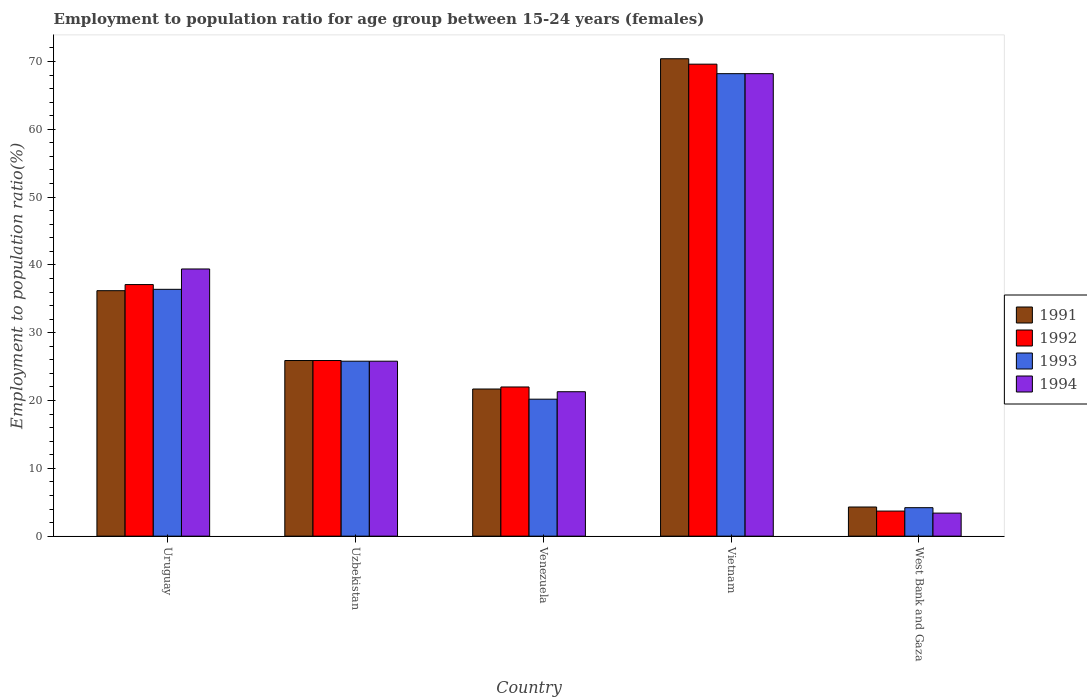How many different coloured bars are there?
Ensure brevity in your answer.  4. How many bars are there on the 4th tick from the right?
Provide a succinct answer. 4. What is the label of the 2nd group of bars from the left?
Your answer should be very brief. Uzbekistan. What is the employment to population ratio in 1993 in Uzbekistan?
Make the answer very short. 25.8. Across all countries, what is the maximum employment to population ratio in 1993?
Your response must be concise. 68.2. Across all countries, what is the minimum employment to population ratio in 1991?
Offer a terse response. 4.3. In which country was the employment to population ratio in 1993 maximum?
Provide a succinct answer. Vietnam. In which country was the employment to population ratio in 1992 minimum?
Provide a succinct answer. West Bank and Gaza. What is the total employment to population ratio in 1993 in the graph?
Keep it short and to the point. 154.8. What is the difference between the employment to population ratio in 1993 in Venezuela and that in Vietnam?
Offer a terse response. -48. What is the difference between the employment to population ratio in 1991 in Uzbekistan and the employment to population ratio in 1992 in Venezuela?
Your response must be concise. 3.9. What is the average employment to population ratio in 1993 per country?
Provide a succinct answer. 30.96. What is the difference between the employment to population ratio of/in 1993 and employment to population ratio of/in 1992 in Venezuela?
Provide a short and direct response. -1.8. In how many countries, is the employment to population ratio in 1991 greater than 8 %?
Offer a very short reply. 4. What is the ratio of the employment to population ratio in 1993 in Vietnam to that in West Bank and Gaza?
Provide a succinct answer. 16.24. Is the employment to population ratio in 1993 in Uruguay less than that in West Bank and Gaza?
Provide a succinct answer. No. What is the difference between the highest and the second highest employment to population ratio in 1992?
Make the answer very short. -11.2. What is the difference between the highest and the lowest employment to population ratio in 1991?
Provide a succinct answer. 66.1. Is it the case that in every country, the sum of the employment to population ratio in 1993 and employment to population ratio in 1991 is greater than the sum of employment to population ratio in 1992 and employment to population ratio in 1994?
Give a very brief answer. No. What does the 4th bar from the left in Venezuela represents?
Make the answer very short. 1994. What does the 2nd bar from the right in Venezuela represents?
Make the answer very short. 1993. How many bars are there?
Offer a very short reply. 20. How many countries are there in the graph?
Keep it short and to the point. 5. What is the difference between two consecutive major ticks on the Y-axis?
Give a very brief answer. 10. Are the values on the major ticks of Y-axis written in scientific E-notation?
Provide a succinct answer. No. Does the graph contain any zero values?
Your answer should be very brief. No. Does the graph contain grids?
Your answer should be compact. No. How many legend labels are there?
Give a very brief answer. 4. How are the legend labels stacked?
Ensure brevity in your answer.  Vertical. What is the title of the graph?
Your response must be concise. Employment to population ratio for age group between 15-24 years (females). Does "1976" appear as one of the legend labels in the graph?
Your response must be concise. No. What is the label or title of the X-axis?
Your response must be concise. Country. What is the label or title of the Y-axis?
Make the answer very short. Employment to population ratio(%). What is the Employment to population ratio(%) of 1991 in Uruguay?
Offer a terse response. 36.2. What is the Employment to population ratio(%) of 1992 in Uruguay?
Give a very brief answer. 37.1. What is the Employment to population ratio(%) in 1993 in Uruguay?
Provide a short and direct response. 36.4. What is the Employment to population ratio(%) of 1994 in Uruguay?
Provide a succinct answer. 39.4. What is the Employment to population ratio(%) in 1991 in Uzbekistan?
Offer a terse response. 25.9. What is the Employment to population ratio(%) of 1992 in Uzbekistan?
Ensure brevity in your answer.  25.9. What is the Employment to population ratio(%) in 1993 in Uzbekistan?
Make the answer very short. 25.8. What is the Employment to population ratio(%) of 1994 in Uzbekistan?
Your response must be concise. 25.8. What is the Employment to population ratio(%) in 1991 in Venezuela?
Offer a very short reply. 21.7. What is the Employment to population ratio(%) of 1992 in Venezuela?
Your answer should be very brief. 22. What is the Employment to population ratio(%) of 1993 in Venezuela?
Ensure brevity in your answer.  20.2. What is the Employment to population ratio(%) in 1994 in Venezuela?
Provide a short and direct response. 21.3. What is the Employment to population ratio(%) of 1991 in Vietnam?
Offer a very short reply. 70.4. What is the Employment to population ratio(%) in 1992 in Vietnam?
Make the answer very short. 69.6. What is the Employment to population ratio(%) in 1993 in Vietnam?
Your answer should be very brief. 68.2. What is the Employment to population ratio(%) in 1994 in Vietnam?
Offer a terse response. 68.2. What is the Employment to population ratio(%) in 1991 in West Bank and Gaza?
Offer a terse response. 4.3. What is the Employment to population ratio(%) in 1992 in West Bank and Gaza?
Your answer should be very brief. 3.7. What is the Employment to population ratio(%) in 1993 in West Bank and Gaza?
Your response must be concise. 4.2. What is the Employment to population ratio(%) in 1994 in West Bank and Gaza?
Offer a very short reply. 3.4. Across all countries, what is the maximum Employment to population ratio(%) in 1991?
Keep it short and to the point. 70.4. Across all countries, what is the maximum Employment to population ratio(%) of 1992?
Ensure brevity in your answer.  69.6. Across all countries, what is the maximum Employment to population ratio(%) in 1993?
Your response must be concise. 68.2. Across all countries, what is the maximum Employment to population ratio(%) in 1994?
Ensure brevity in your answer.  68.2. Across all countries, what is the minimum Employment to population ratio(%) of 1991?
Your response must be concise. 4.3. Across all countries, what is the minimum Employment to population ratio(%) in 1992?
Your answer should be compact. 3.7. Across all countries, what is the minimum Employment to population ratio(%) of 1993?
Provide a short and direct response. 4.2. Across all countries, what is the minimum Employment to population ratio(%) in 1994?
Ensure brevity in your answer.  3.4. What is the total Employment to population ratio(%) of 1991 in the graph?
Ensure brevity in your answer.  158.5. What is the total Employment to population ratio(%) in 1992 in the graph?
Make the answer very short. 158.3. What is the total Employment to population ratio(%) of 1993 in the graph?
Keep it short and to the point. 154.8. What is the total Employment to population ratio(%) in 1994 in the graph?
Keep it short and to the point. 158.1. What is the difference between the Employment to population ratio(%) of 1991 in Uruguay and that in Uzbekistan?
Your answer should be very brief. 10.3. What is the difference between the Employment to population ratio(%) of 1993 in Uruguay and that in Uzbekistan?
Make the answer very short. 10.6. What is the difference between the Employment to population ratio(%) of 1994 in Uruguay and that in Uzbekistan?
Offer a very short reply. 13.6. What is the difference between the Employment to population ratio(%) of 1992 in Uruguay and that in Venezuela?
Offer a very short reply. 15.1. What is the difference between the Employment to population ratio(%) in 1993 in Uruguay and that in Venezuela?
Your answer should be compact. 16.2. What is the difference between the Employment to population ratio(%) of 1994 in Uruguay and that in Venezuela?
Ensure brevity in your answer.  18.1. What is the difference between the Employment to population ratio(%) of 1991 in Uruguay and that in Vietnam?
Provide a short and direct response. -34.2. What is the difference between the Employment to population ratio(%) in 1992 in Uruguay and that in Vietnam?
Ensure brevity in your answer.  -32.5. What is the difference between the Employment to population ratio(%) of 1993 in Uruguay and that in Vietnam?
Offer a terse response. -31.8. What is the difference between the Employment to population ratio(%) in 1994 in Uruguay and that in Vietnam?
Your answer should be very brief. -28.8. What is the difference between the Employment to population ratio(%) in 1991 in Uruguay and that in West Bank and Gaza?
Your response must be concise. 31.9. What is the difference between the Employment to population ratio(%) of 1992 in Uruguay and that in West Bank and Gaza?
Keep it short and to the point. 33.4. What is the difference between the Employment to population ratio(%) in 1993 in Uruguay and that in West Bank and Gaza?
Your answer should be very brief. 32.2. What is the difference between the Employment to population ratio(%) in 1994 in Uruguay and that in West Bank and Gaza?
Make the answer very short. 36. What is the difference between the Employment to population ratio(%) of 1991 in Uzbekistan and that in Venezuela?
Ensure brevity in your answer.  4.2. What is the difference between the Employment to population ratio(%) in 1992 in Uzbekistan and that in Venezuela?
Give a very brief answer. 3.9. What is the difference between the Employment to population ratio(%) of 1993 in Uzbekistan and that in Venezuela?
Offer a terse response. 5.6. What is the difference between the Employment to population ratio(%) in 1991 in Uzbekistan and that in Vietnam?
Your answer should be very brief. -44.5. What is the difference between the Employment to population ratio(%) in 1992 in Uzbekistan and that in Vietnam?
Offer a terse response. -43.7. What is the difference between the Employment to population ratio(%) in 1993 in Uzbekistan and that in Vietnam?
Make the answer very short. -42.4. What is the difference between the Employment to population ratio(%) in 1994 in Uzbekistan and that in Vietnam?
Keep it short and to the point. -42.4. What is the difference between the Employment to population ratio(%) of 1991 in Uzbekistan and that in West Bank and Gaza?
Offer a very short reply. 21.6. What is the difference between the Employment to population ratio(%) in 1992 in Uzbekistan and that in West Bank and Gaza?
Your response must be concise. 22.2. What is the difference between the Employment to population ratio(%) in 1993 in Uzbekistan and that in West Bank and Gaza?
Provide a short and direct response. 21.6. What is the difference between the Employment to population ratio(%) in 1994 in Uzbekistan and that in West Bank and Gaza?
Provide a succinct answer. 22.4. What is the difference between the Employment to population ratio(%) of 1991 in Venezuela and that in Vietnam?
Keep it short and to the point. -48.7. What is the difference between the Employment to population ratio(%) of 1992 in Venezuela and that in Vietnam?
Offer a terse response. -47.6. What is the difference between the Employment to population ratio(%) in 1993 in Venezuela and that in Vietnam?
Offer a terse response. -48. What is the difference between the Employment to population ratio(%) in 1994 in Venezuela and that in Vietnam?
Provide a succinct answer. -46.9. What is the difference between the Employment to population ratio(%) of 1991 in Venezuela and that in West Bank and Gaza?
Offer a terse response. 17.4. What is the difference between the Employment to population ratio(%) in 1994 in Venezuela and that in West Bank and Gaza?
Your answer should be very brief. 17.9. What is the difference between the Employment to population ratio(%) in 1991 in Vietnam and that in West Bank and Gaza?
Your answer should be compact. 66.1. What is the difference between the Employment to population ratio(%) of 1992 in Vietnam and that in West Bank and Gaza?
Offer a terse response. 65.9. What is the difference between the Employment to population ratio(%) in 1993 in Vietnam and that in West Bank and Gaza?
Your answer should be compact. 64. What is the difference between the Employment to population ratio(%) of 1994 in Vietnam and that in West Bank and Gaza?
Offer a very short reply. 64.8. What is the difference between the Employment to population ratio(%) in 1992 in Uruguay and the Employment to population ratio(%) in 1993 in Uzbekistan?
Provide a short and direct response. 11.3. What is the difference between the Employment to population ratio(%) of 1992 in Uruguay and the Employment to population ratio(%) of 1994 in Uzbekistan?
Your answer should be very brief. 11.3. What is the difference between the Employment to population ratio(%) in 1991 in Uruguay and the Employment to population ratio(%) in 1992 in Venezuela?
Keep it short and to the point. 14.2. What is the difference between the Employment to population ratio(%) of 1991 in Uruguay and the Employment to population ratio(%) of 1993 in Venezuela?
Offer a very short reply. 16. What is the difference between the Employment to population ratio(%) in 1991 in Uruguay and the Employment to population ratio(%) in 1994 in Venezuela?
Your response must be concise. 14.9. What is the difference between the Employment to population ratio(%) in 1993 in Uruguay and the Employment to population ratio(%) in 1994 in Venezuela?
Make the answer very short. 15.1. What is the difference between the Employment to population ratio(%) of 1991 in Uruguay and the Employment to population ratio(%) of 1992 in Vietnam?
Keep it short and to the point. -33.4. What is the difference between the Employment to population ratio(%) of 1991 in Uruguay and the Employment to population ratio(%) of 1993 in Vietnam?
Your answer should be compact. -32. What is the difference between the Employment to population ratio(%) in 1991 in Uruguay and the Employment to population ratio(%) in 1994 in Vietnam?
Keep it short and to the point. -32. What is the difference between the Employment to population ratio(%) of 1992 in Uruguay and the Employment to population ratio(%) of 1993 in Vietnam?
Your answer should be compact. -31.1. What is the difference between the Employment to population ratio(%) of 1992 in Uruguay and the Employment to population ratio(%) of 1994 in Vietnam?
Provide a succinct answer. -31.1. What is the difference between the Employment to population ratio(%) in 1993 in Uruguay and the Employment to population ratio(%) in 1994 in Vietnam?
Ensure brevity in your answer.  -31.8. What is the difference between the Employment to population ratio(%) of 1991 in Uruguay and the Employment to population ratio(%) of 1992 in West Bank and Gaza?
Provide a succinct answer. 32.5. What is the difference between the Employment to population ratio(%) in 1991 in Uruguay and the Employment to population ratio(%) in 1993 in West Bank and Gaza?
Give a very brief answer. 32. What is the difference between the Employment to population ratio(%) in 1991 in Uruguay and the Employment to population ratio(%) in 1994 in West Bank and Gaza?
Provide a succinct answer. 32.8. What is the difference between the Employment to population ratio(%) of 1992 in Uruguay and the Employment to population ratio(%) of 1993 in West Bank and Gaza?
Provide a succinct answer. 32.9. What is the difference between the Employment to population ratio(%) in 1992 in Uruguay and the Employment to population ratio(%) in 1994 in West Bank and Gaza?
Provide a short and direct response. 33.7. What is the difference between the Employment to population ratio(%) in 1991 in Uzbekistan and the Employment to population ratio(%) in 1994 in Venezuela?
Provide a short and direct response. 4.6. What is the difference between the Employment to population ratio(%) in 1992 in Uzbekistan and the Employment to population ratio(%) in 1994 in Venezuela?
Keep it short and to the point. 4.6. What is the difference between the Employment to population ratio(%) of 1993 in Uzbekistan and the Employment to population ratio(%) of 1994 in Venezuela?
Offer a very short reply. 4.5. What is the difference between the Employment to population ratio(%) in 1991 in Uzbekistan and the Employment to population ratio(%) in 1992 in Vietnam?
Provide a succinct answer. -43.7. What is the difference between the Employment to population ratio(%) in 1991 in Uzbekistan and the Employment to population ratio(%) in 1993 in Vietnam?
Your answer should be compact. -42.3. What is the difference between the Employment to population ratio(%) in 1991 in Uzbekistan and the Employment to population ratio(%) in 1994 in Vietnam?
Your response must be concise. -42.3. What is the difference between the Employment to population ratio(%) of 1992 in Uzbekistan and the Employment to population ratio(%) of 1993 in Vietnam?
Offer a very short reply. -42.3. What is the difference between the Employment to population ratio(%) of 1992 in Uzbekistan and the Employment to population ratio(%) of 1994 in Vietnam?
Your answer should be compact. -42.3. What is the difference between the Employment to population ratio(%) of 1993 in Uzbekistan and the Employment to population ratio(%) of 1994 in Vietnam?
Provide a succinct answer. -42.4. What is the difference between the Employment to population ratio(%) of 1991 in Uzbekistan and the Employment to population ratio(%) of 1993 in West Bank and Gaza?
Offer a terse response. 21.7. What is the difference between the Employment to population ratio(%) in 1992 in Uzbekistan and the Employment to population ratio(%) in 1993 in West Bank and Gaza?
Your answer should be compact. 21.7. What is the difference between the Employment to population ratio(%) of 1992 in Uzbekistan and the Employment to population ratio(%) of 1994 in West Bank and Gaza?
Your response must be concise. 22.5. What is the difference between the Employment to population ratio(%) of 1993 in Uzbekistan and the Employment to population ratio(%) of 1994 in West Bank and Gaza?
Keep it short and to the point. 22.4. What is the difference between the Employment to population ratio(%) in 1991 in Venezuela and the Employment to population ratio(%) in 1992 in Vietnam?
Make the answer very short. -47.9. What is the difference between the Employment to population ratio(%) of 1991 in Venezuela and the Employment to population ratio(%) of 1993 in Vietnam?
Offer a terse response. -46.5. What is the difference between the Employment to population ratio(%) in 1991 in Venezuela and the Employment to population ratio(%) in 1994 in Vietnam?
Give a very brief answer. -46.5. What is the difference between the Employment to population ratio(%) of 1992 in Venezuela and the Employment to population ratio(%) of 1993 in Vietnam?
Your answer should be very brief. -46.2. What is the difference between the Employment to population ratio(%) in 1992 in Venezuela and the Employment to population ratio(%) in 1994 in Vietnam?
Give a very brief answer. -46.2. What is the difference between the Employment to population ratio(%) of 1993 in Venezuela and the Employment to population ratio(%) of 1994 in Vietnam?
Offer a terse response. -48. What is the difference between the Employment to population ratio(%) in 1991 in Venezuela and the Employment to population ratio(%) in 1992 in West Bank and Gaza?
Provide a succinct answer. 18. What is the difference between the Employment to population ratio(%) of 1991 in Venezuela and the Employment to population ratio(%) of 1993 in West Bank and Gaza?
Offer a terse response. 17.5. What is the difference between the Employment to population ratio(%) in 1992 in Venezuela and the Employment to population ratio(%) in 1993 in West Bank and Gaza?
Give a very brief answer. 17.8. What is the difference between the Employment to population ratio(%) of 1992 in Venezuela and the Employment to population ratio(%) of 1994 in West Bank and Gaza?
Make the answer very short. 18.6. What is the difference between the Employment to population ratio(%) in 1991 in Vietnam and the Employment to population ratio(%) in 1992 in West Bank and Gaza?
Give a very brief answer. 66.7. What is the difference between the Employment to population ratio(%) of 1991 in Vietnam and the Employment to population ratio(%) of 1993 in West Bank and Gaza?
Ensure brevity in your answer.  66.2. What is the difference between the Employment to population ratio(%) of 1992 in Vietnam and the Employment to population ratio(%) of 1993 in West Bank and Gaza?
Keep it short and to the point. 65.4. What is the difference between the Employment to population ratio(%) of 1992 in Vietnam and the Employment to population ratio(%) of 1994 in West Bank and Gaza?
Give a very brief answer. 66.2. What is the difference between the Employment to population ratio(%) in 1993 in Vietnam and the Employment to population ratio(%) in 1994 in West Bank and Gaza?
Offer a terse response. 64.8. What is the average Employment to population ratio(%) in 1991 per country?
Your answer should be very brief. 31.7. What is the average Employment to population ratio(%) of 1992 per country?
Offer a terse response. 31.66. What is the average Employment to population ratio(%) of 1993 per country?
Keep it short and to the point. 30.96. What is the average Employment to population ratio(%) in 1994 per country?
Your answer should be very brief. 31.62. What is the difference between the Employment to population ratio(%) of 1991 and Employment to population ratio(%) of 1993 in Uruguay?
Provide a succinct answer. -0.2. What is the difference between the Employment to population ratio(%) of 1992 and Employment to population ratio(%) of 1993 in Uruguay?
Your answer should be very brief. 0.7. What is the difference between the Employment to population ratio(%) of 1991 and Employment to population ratio(%) of 1993 in Uzbekistan?
Your response must be concise. 0.1. What is the difference between the Employment to population ratio(%) of 1991 and Employment to population ratio(%) of 1994 in Uzbekistan?
Keep it short and to the point. 0.1. What is the difference between the Employment to population ratio(%) in 1993 and Employment to population ratio(%) in 1994 in Uzbekistan?
Provide a short and direct response. 0. What is the difference between the Employment to population ratio(%) of 1991 and Employment to population ratio(%) of 1994 in Vietnam?
Your answer should be very brief. 2.2. What is the difference between the Employment to population ratio(%) of 1992 and Employment to population ratio(%) of 1993 in Vietnam?
Your answer should be very brief. 1.4. What is the difference between the Employment to population ratio(%) in 1992 and Employment to population ratio(%) in 1994 in Vietnam?
Provide a short and direct response. 1.4. What is the difference between the Employment to population ratio(%) of 1993 and Employment to population ratio(%) of 1994 in Vietnam?
Offer a very short reply. 0. What is the difference between the Employment to population ratio(%) of 1991 and Employment to population ratio(%) of 1992 in West Bank and Gaza?
Your answer should be compact. 0.6. What is the difference between the Employment to population ratio(%) in 1991 and Employment to population ratio(%) in 1993 in West Bank and Gaza?
Your answer should be very brief. 0.1. What is the difference between the Employment to population ratio(%) in 1991 and Employment to population ratio(%) in 1994 in West Bank and Gaza?
Ensure brevity in your answer.  0.9. What is the difference between the Employment to population ratio(%) in 1992 and Employment to population ratio(%) in 1993 in West Bank and Gaza?
Your response must be concise. -0.5. What is the difference between the Employment to population ratio(%) of 1993 and Employment to population ratio(%) of 1994 in West Bank and Gaza?
Ensure brevity in your answer.  0.8. What is the ratio of the Employment to population ratio(%) of 1991 in Uruguay to that in Uzbekistan?
Make the answer very short. 1.4. What is the ratio of the Employment to population ratio(%) in 1992 in Uruguay to that in Uzbekistan?
Offer a very short reply. 1.43. What is the ratio of the Employment to population ratio(%) in 1993 in Uruguay to that in Uzbekistan?
Give a very brief answer. 1.41. What is the ratio of the Employment to population ratio(%) in 1994 in Uruguay to that in Uzbekistan?
Keep it short and to the point. 1.53. What is the ratio of the Employment to population ratio(%) in 1991 in Uruguay to that in Venezuela?
Make the answer very short. 1.67. What is the ratio of the Employment to population ratio(%) in 1992 in Uruguay to that in Venezuela?
Your response must be concise. 1.69. What is the ratio of the Employment to population ratio(%) of 1993 in Uruguay to that in Venezuela?
Provide a succinct answer. 1.8. What is the ratio of the Employment to population ratio(%) in 1994 in Uruguay to that in Venezuela?
Provide a succinct answer. 1.85. What is the ratio of the Employment to population ratio(%) of 1991 in Uruguay to that in Vietnam?
Ensure brevity in your answer.  0.51. What is the ratio of the Employment to population ratio(%) of 1992 in Uruguay to that in Vietnam?
Offer a terse response. 0.53. What is the ratio of the Employment to population ratio(%) in 1993 in Uruguay to that in Vietnam?
Provide a succinct answer. 0.53. What is the ratio of the Employment to population ratio(%) of 1994 in Uruguay to that in Vietnam?
Your response must be concise. 0.58. What is the ratio of the Employment to population ratio(%) in 1991 in Uruguay to that in West Bank and Gaza?
Provide a short and direct response. 8.42. What is the ratio of the Employment to population ratio(%) in 1992 in Uruguay to that in West Bank and Gaza?
Offer a terse response. 10.03. What is the ratio of the Employment to population ratio(%) of 1993 in Uruguay to that in West Bank and Gaza?
Your answer should be very brief. 8.67. What is the ratio of the Employment to population ratio(%) in 1994 in Uruguay to that in West Bank and Gaza?
Offer a very short reply. 11.59. What is the ratio of the Employment to population ratio(%) of 1991 in Uzbekistan to that in Venezuela?
Offer a very short reply. 1.19. What is the ratio of the Employment to population ratio(%) of 1992 in Uzbekistan to that in Venezuela?
Your answer should be very brief. 1.18. What is the ratio of the Employment to population ratio(%) of 1993 in Uzbekistan to that in Venezuela?
Ensure brevity in your answer.  1.28. What is the ratio of the Employment to population ratio(%) of 1994 in Uzbekistan to that in Venezuela?
Ensure brevity in your answer.  1.21. What is the ratio of the Employment to population ratio(%) in 1991 in Uzbekistan to that in Vietnam?
Your response must be concise. 0.37. What is the ratio of the Employment to population ratio(%) in 1992 in Uzbekistan to that in Vietnam?
Your response must be concise. 0.37. What is the ratio of the Employment to population ratio(%) in 1993 in Uzbekistan to that in Vietnam?
Your answer should be compact. 0.38. What is the ratio of the Employment to population ratio(%) of 1994 in Uzbekistan to that in Vietnam?
Your answer should be very brief. 0.38. What is the ratio of the Employment to population ratio(%) of 1991 in Uzbekistan to that in West Bank and Gaza?
Offer a terse response. 6.02. What is the ratio of the Employment to population ratio(%) in 1992 in Uzbekistan to that in West Bank and Gaza?
Your response must be concise. 7. What is the ratio of the Employment to population ratio(%) of 1993 in Uzbekistan to that in West Bank and Gaza?
Ensure brevity in your answer.  6.14. What is the ratio of the Employment to population ratio(%) in 1994 in Uzbekistan to that in West Bank and Gaza?
Ensure brevity in your answer.  7.59. What is the ratio of the Employment to population ratio(%) in 1991 in Venezuela to that in Vietnam?
Your answer should be very brief. 0.31. What is the ratio of the Employment to population ratio(%) in 1992 in Venezuela to that in Vietnam?
Offer a terse response. 0.32. What is the ratio of the Employment to population ratio(%) of 1993 in Venezuela to that in Vietnam?
Offer a terse response. 0.3. What is the ratio of the Employment to population ratio(%) in 1994 in Venezuela to that in Vietnam?
Give a very brief answer. 0.31. What is the ratio of the Employment to population ratio(%) in 1991 in Venezuela to that in West Bank and Gaza?
Give a very brief answer. 5.05. What is the ratio of the Employment to population ratio(%) of 1992 in Venezuela to that in West Bank and Gaza?
Make the answer very short. 5.95. What is the ratio of the Employment to population ratio(%) of 1993 in Venezuela to that in West Bank and Gaza?
Offer a terse response. 4.81. What is the ratio of the Employment to population ratio(%) in 1994 in Venezuela to that in West Bank and Gaza?
Your answer should be compact. 6.26. What is the ratio of the Employment to population ratio(%) in 1991 in Vietnam to that in West Bank and Gaza?
Ensure brevity in your answer.  16.37. What is the ratio of the Employment to population ratio(%) of 1992 in Vietnam to that in West Bank and Gaza?
Give a very brief answer. 18.81. What is the ratio of the Employment to population ratio(%) in 1993 in Vietnam to that in West Bank and Gaza?
Provide a succinct answer. 16.24. What is the ratio of the Employment to population ratio(%) in 1994 in Vietnam to that in West Bank and Gaza?
Keep it short and to the point. 20.06. What is the difference between the highest and the second highest Employment to population ratio(%) in 1991?
Your answer should be compact. 34.2. What is the difference between the highest and the second highest Employment to population ratio(%) of 1992?
Your response must be concise. 32.5. What is the difference between the highest and the second highest Employment to population ratio(%) in 1993?
Make the answer very short. 31.8. What is the difference between the highest and the second highest Employment to population ratio(%) of 1994?
Provide a succinct answer. 28.8. What is the difference between the highest and the lowest Employment to population ratio(%) in 1991?
Provide a short and direct response. 66.1. What is the difference between the highest and the lowest Employment to population ratio(%) of 1992?
Provide a succinct answer. 65.9. What is the difference between the highest and the lowest Employment to population ratio(%) in 1993?
Keep it short and to the point. 64. What is the difference between the highest and the lowest Employment to population ratio(%) in 1994?
Keep it short and to the point. 64.8. 